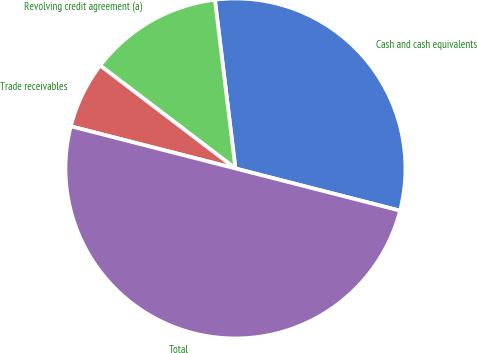Convert chart. <chart><loc_0><loc_0><loc_500><loc_500><pie_chart><fcel>Cash and cash equivalents<fcel>Revolving credit agreement (a)<fcel>Trade receivables<fcel>Total<nl><fcel>30.92%<fcel>12.72%<fcel>6.36%<fcel>50.0%<nl></chart> 